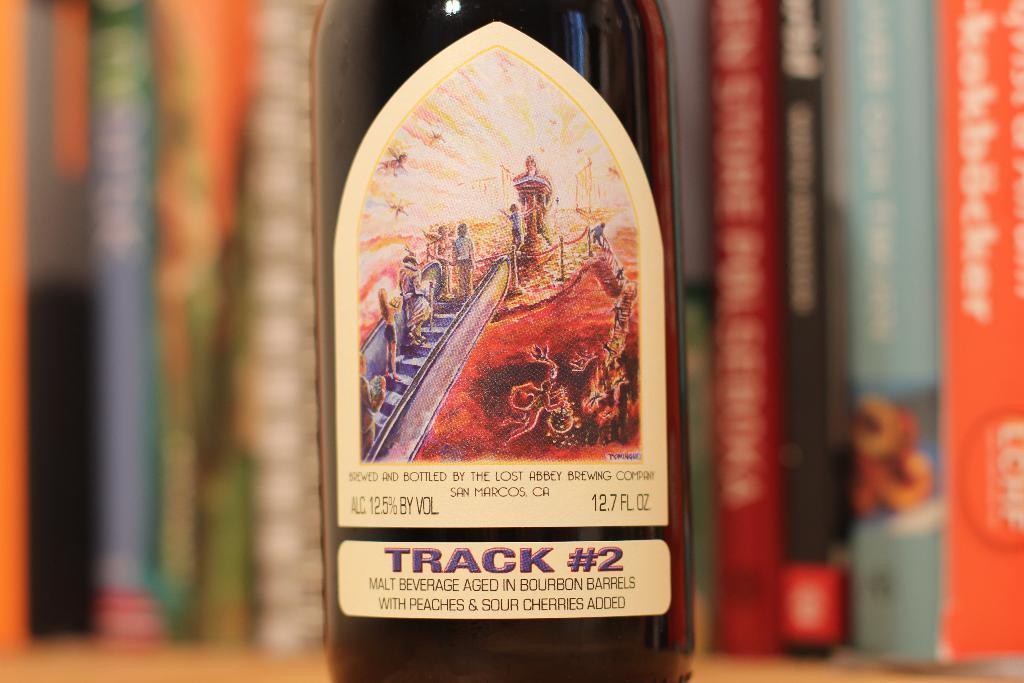Which track is this bottle named after?
Give a very brief answer. 2. How big is the bottle in fluid ounces?
Your response must be concise. 12.7. 